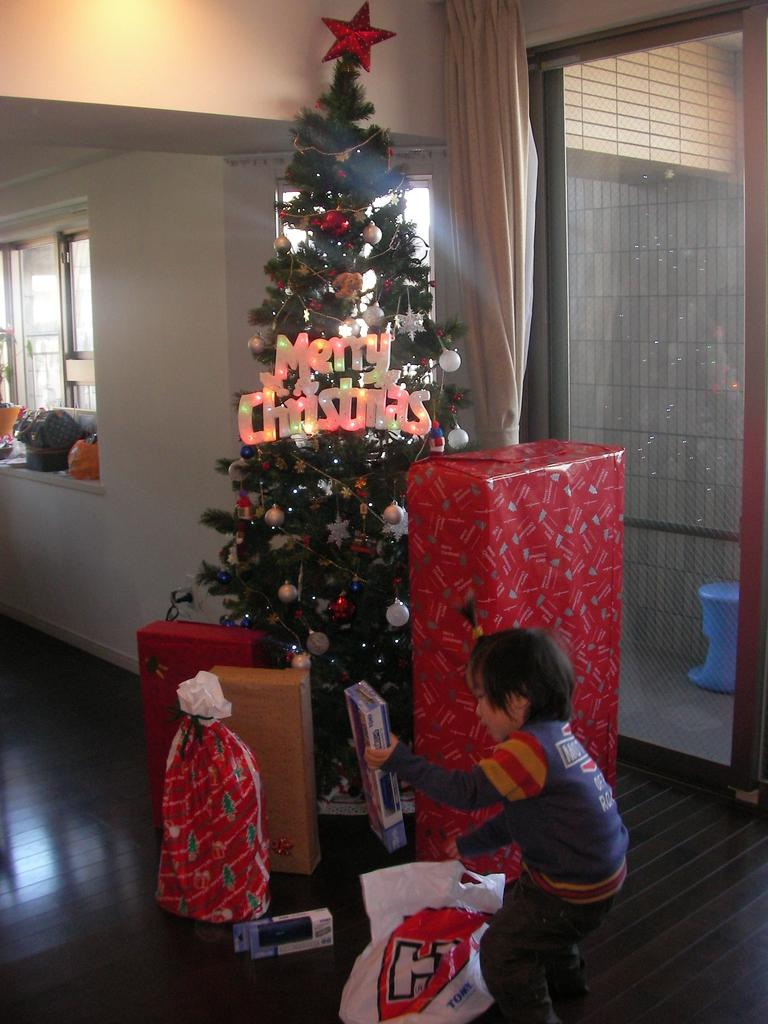<image>
Share a concise interpretation of the image provided. A Christmas tree has the words Merry Christmas on it in lights. 